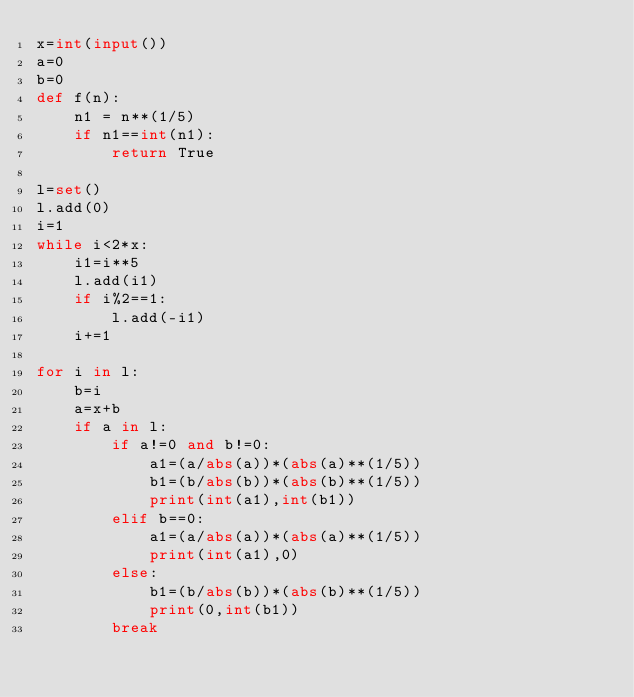<code> <loc_0><loc_0><loc_500><loc_500><_Python_>x=int(input())
a=0
b=0
def f(n):
    n1 = n**(1/5)
    if n1==int(n1):
        return True

l=set()
l.add(0)
i=1
while i<2*x:
    i1=i**5
    l.add(i1)
    if i%2==1:
        l.add(-i1)
    i+=1

for i in l:
    b=i
    a=x+b
    if a in l:
        if a!=0 and b!=0:
            a1=(a/abs(a))*(abs(a)**(1/5))
            b1=(b/abs(b))*(abs(b)**(1/5))
            print(int(a1),int(b1))
        elif b==0:
            a1=(a/abs(a))*(abs(a)**(1/5))
            print(int(a1),0)
        else:
            b1=(b/abs(b))*(abs(b)**(1/5))
            print(0,int(b1))
        break

</code> 